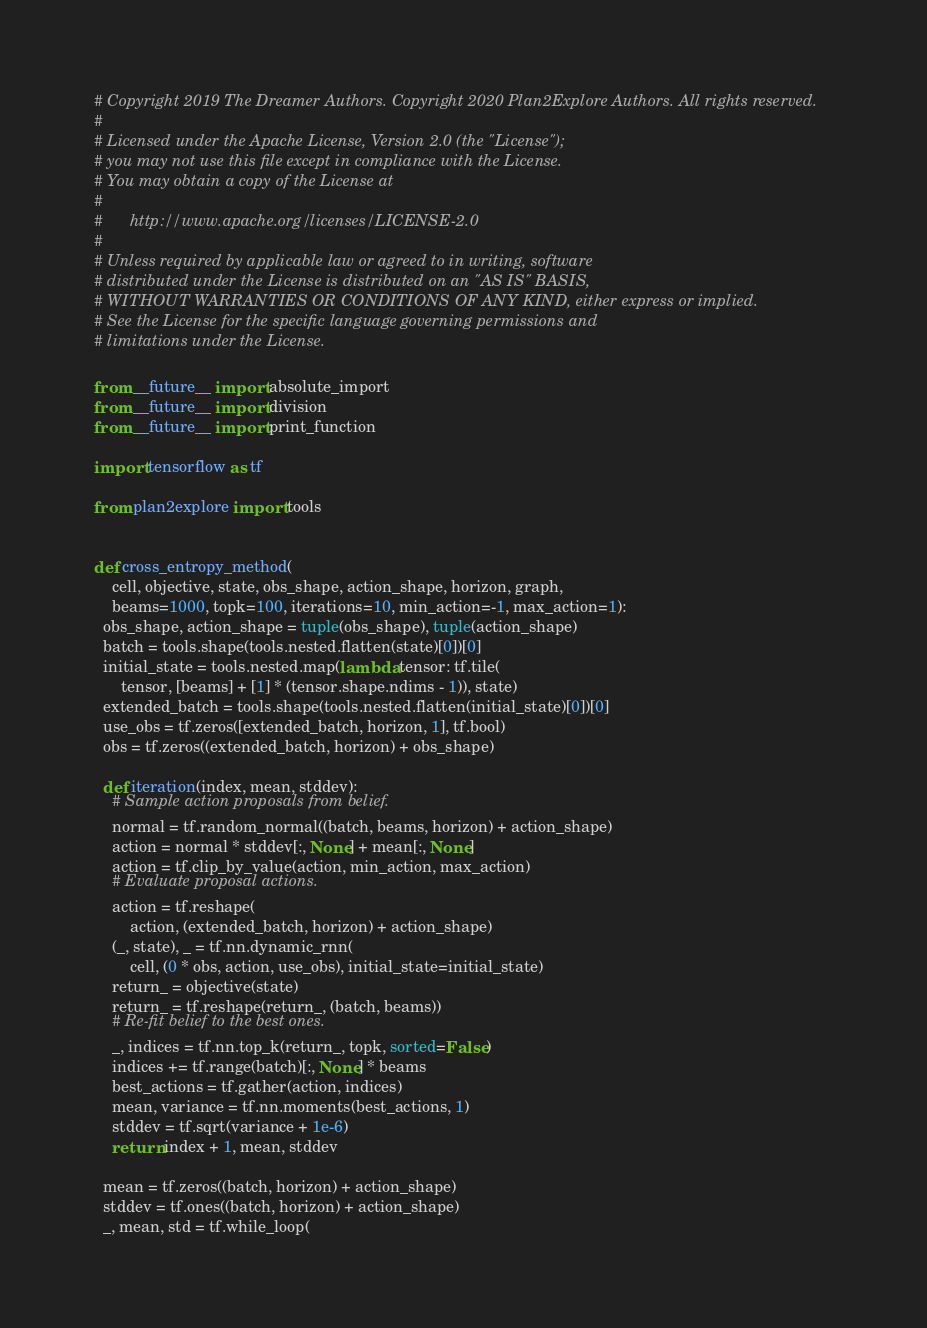Convert code to text. <code><loc_0><loc_0><loc_500><loc_500><_Python_># Copyright 2019 The Dreamer Authors. Copyright 2020 Plan2Explore Authors. All rights reserved.
#
# Licensed under the Apache License, Version 2.0 (the "License");
# you may not use this file except in compliance with the License.
# You may obtain a copy of the License at
#
#      http://www.apache.org/licenses/LICENSE-2.0
#
# Unless required by applicable law or agreed to in writing, software
# distributed under the License is distributed on an "AS IS" BASIS,
# WITHOUT WARRANTIES OR CONDITIONS OF ANY KIND, either express or implied.
# See the License for the specific language governing permissions and
# limitations under the License.

from __future__ import absolute_import
from __future__ import division
from __future__ import print_function

import tensorflow as tf

from plan2explore import tools


def cross_entropy_method(
    cell, objective, state, obs_shape, action_shape, horizon, graph,
    beams=1000, topk=100, iterations=10, min_action=-1, max_action=1):
  obs_shape, action_shape = tuple(obs_shape), tuple(action_shape)
  batch = tools.shape(tools.nested.flatten(state)[0])[0]
  initial_state = tools.nested.map(lambda tensor: tf.tile(
      tensor, [beams] + [1] * (tensor.shape.ndims - 1)), state)
  extended_batch = tools.shape(tools.nested.flatten(initial_state)[0])[0]
  use_obs = tf.zeros([extended_batch, horizon, 1], tf.bool)
  obs = tf.zeros((extended_batch, horizon) + obs_shape)

  def iteration(index, mean, stddev):
    # Sample action proposals from belief.
    normal = tf.random_normal((batch, beams, horizon) + action_shape)
    action = normal * stddev[:, None] + mean[:, None]
    action = tf.clip_by_value(action, min_action, max_action)
    # Evaluate proposal actions.
    action = tf.reshape(
        action, (extended_batch, horizon) + action_shape)
    (_, state), _ = tf.nn.dynamic_rnn(
        cell, (0 * obs, action, use_obs), initial_state=initial_state)
    return_ = objective(state)
    return_ = tf.reshape(return_, (batch, beams))
    # Re-fit belief to the best ones.
    _, indices = tf.nn.top_k(return_, topk, sorted=False)
    indices += tf.range(batch)[:, None] * beams
    best_actions = tf.gather(action, indices)
    mean, variance = tf.nn.moments(best_actions, 1)
    stddev = tf.sqrt(variance + 1e-6)
    return index + 1, mean, stddev

  mean = tf.zeros((batch, horizon) + action_shape)
  stddev = tf.ones((batch, horizon) + action_shape)
  _, mean, std = tf.while_loop(</code> 